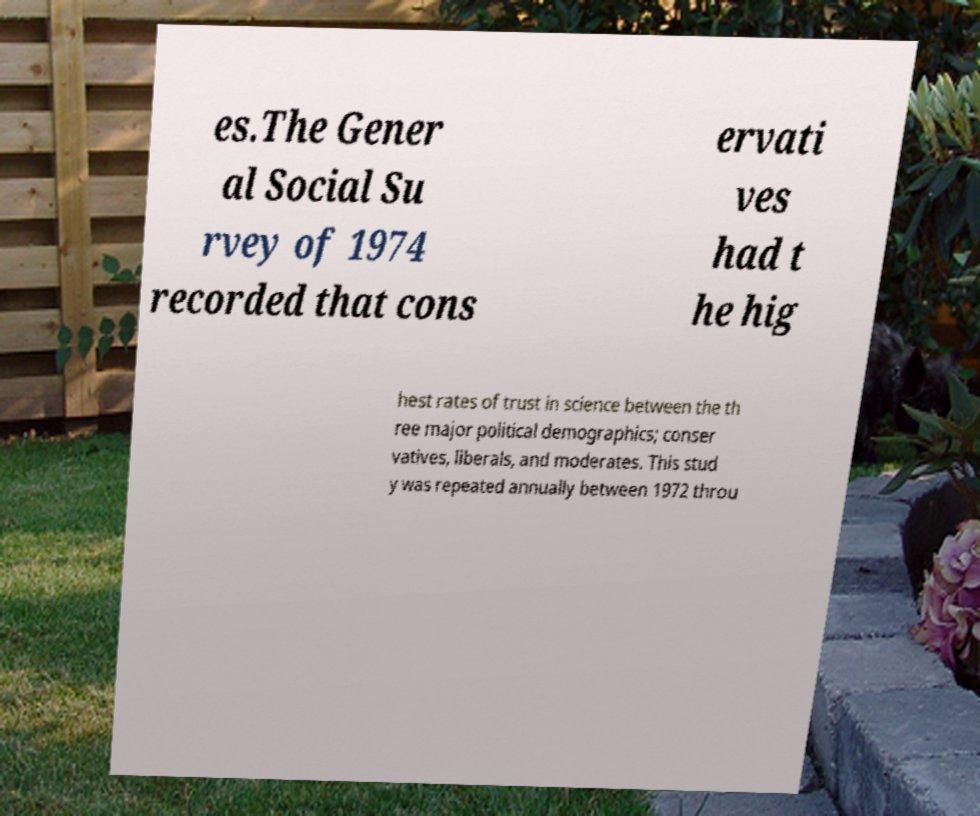Could you assist in decoding the text presented in this image and type it out clearly? es.The Gener al Social Su rvey of 1974 recorded that cons ervati ves had t he hig hest rates of trust in science between the th ree major political demographics; conser vatives, liberals, and moderates. This stud y was repeated annually between 1972 throu 